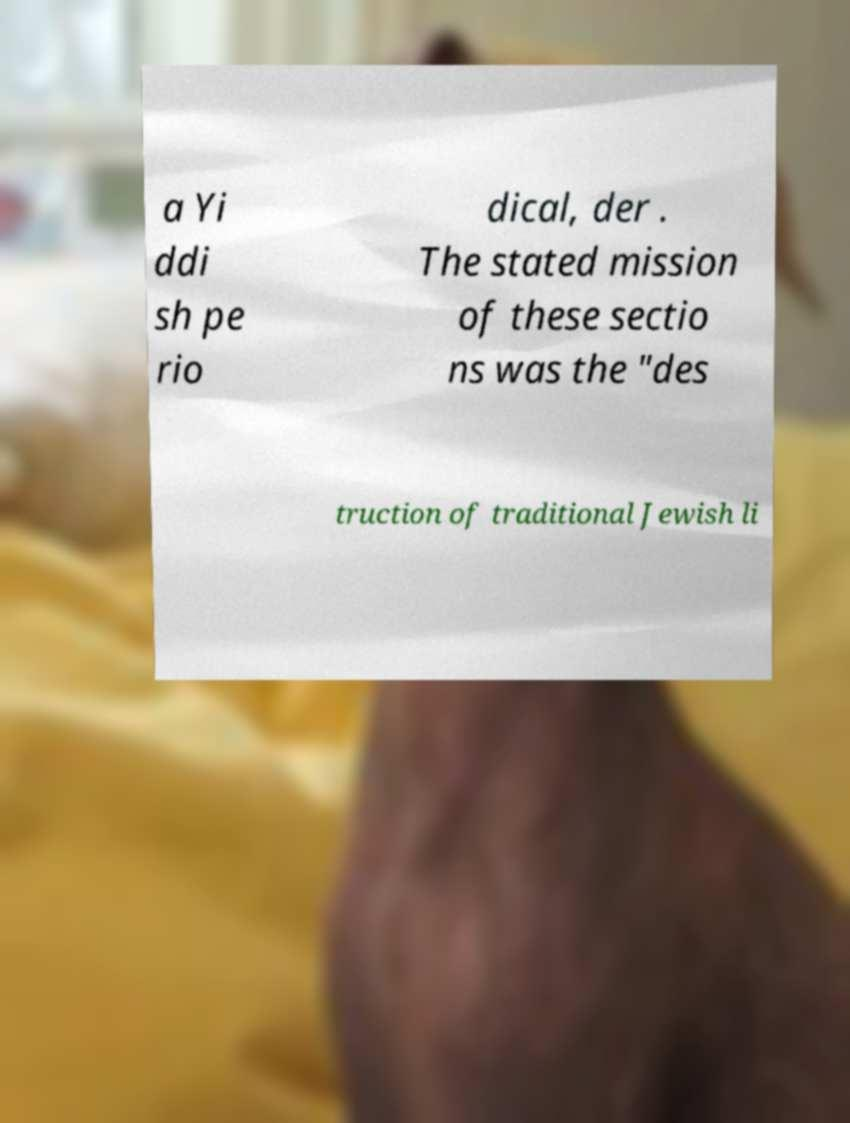Please identify and transcribe the text found in this image. a Yi ddi sh pe rio dical, der . The stated mission of these sectio ns was the "des truction of traditional Jewish li 